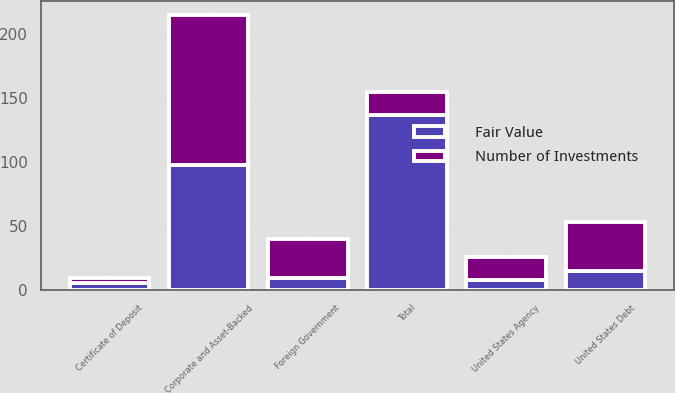<chart> <loc_0><loc_0><loc_500><loc_500><stacked_bar_chart><ecel><fcel>Corporate and Asset-Backed<fcel>Foreign Government<fcel>United States Agency<fcel>United States Debt<fcel>Certificate of Deposit<fcel>Total<nl><fcel>Fair Value<fcel>98<fcel>10<fcel>8<fcel>15<fcel>6<fcel>137<nl><fcel>Number of Investments<fcel>117<fcel>30<fcel>18<fcel>38<fcel>4<fcel>18<nl></chart> 